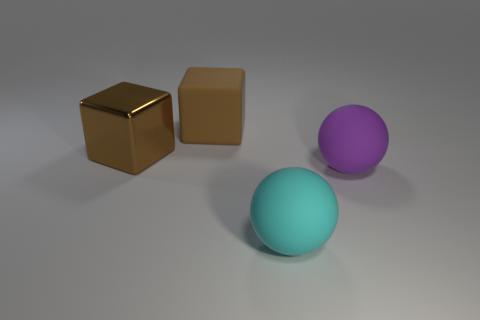Can you describe the lighting setup implied in this image? The lighting in the image suggests a single, diffuse overhead light source positioned slightly in front of the objects. The soft shadows behind the objects indicate that the light is not overly harsh or direct, creating a calm and evenly lit scene. 